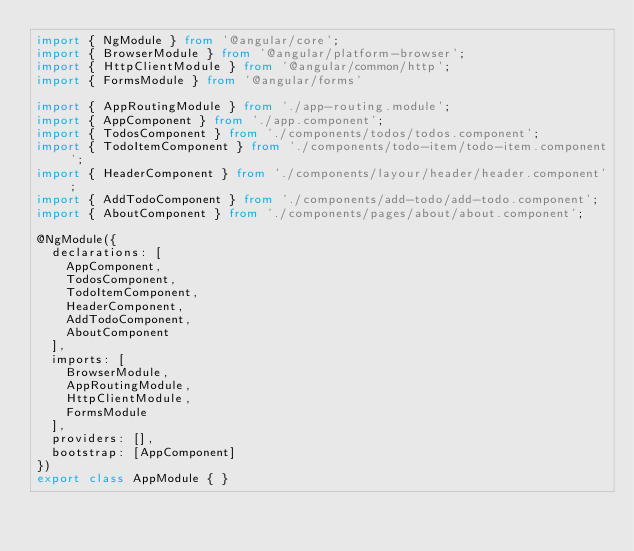<code> <loc_0><loc_0><loc_500><loc_500><_TypeScript_>import { NgModule } from '@angular/core';
import { BrowserModule } from '@angular/platform-browser';
import { HttpClientModule } from '@angular/common/http';
import { FormsModule } from '@angular/forms'

import { AppRoutingModule } from './app-routing.module';
import { AppComponent } from './app.component';
import { TodosComponent } from './components/todos/todos.component';
import { TodoItemComponent } from './components/todo-item/todo-item.component';
import { HeaderComponent } from './components/layour/header/header.component';
import { AddTodoComponent } from './components/add-todo/add-todo.component';
import { AboutComponent } from './components/pages/about/about.component';

@NgModule({
  declarations: [
    AppComponent,
    TodosComponent,
    TodoItemComponent,
    HeaderComponent,
    AddTodoComponent,
    AboutComponent
  ],
  imports: [
    BrowserModule,
    AppRoutingModule,
    HttpClientModule,
    FormsModule
  ],
  providers: [],
  bootstrap: [AppComponent]
})
export class AppModule { }
</code> 